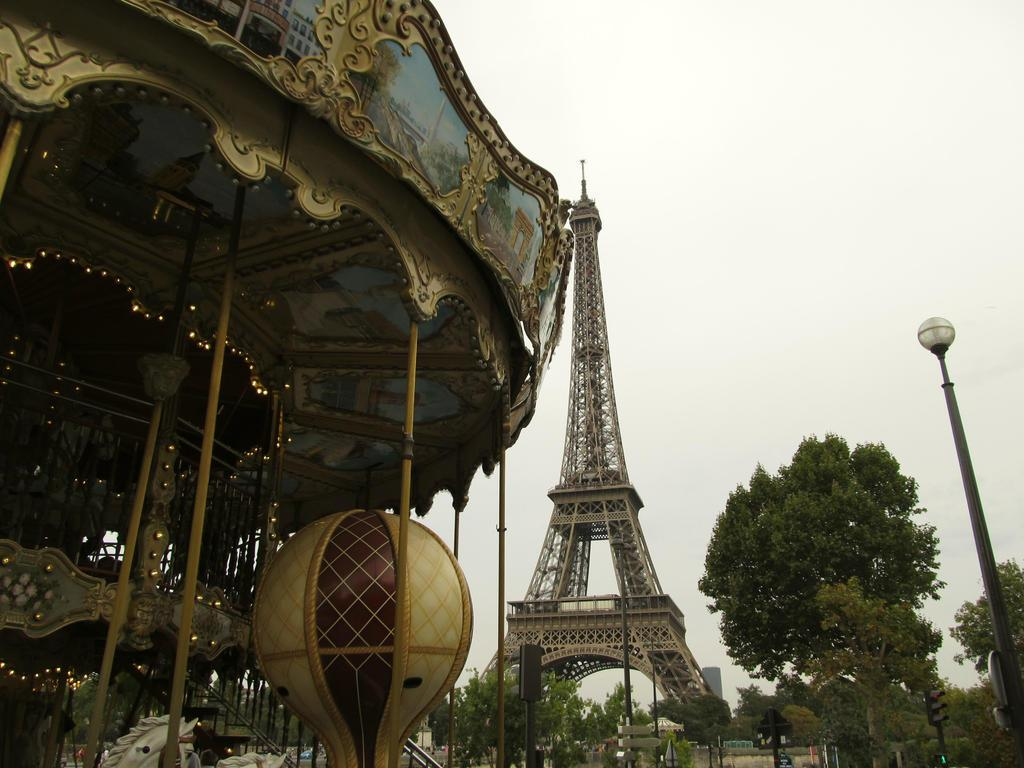What is located on the left side of the image? There is a carousel on the left side of the image. What can be seen on the right side of the image? There is light and trees on the right side of the image. What is visible in the background of the image? There is a tower, buildings, trees, and the sky visible in the background of the image. Can you tell me where the base of the carousel is located in the image? The provided facts do not mention a base for the carousel, so it cannot be determined from the image. What type of bottle is being used to say good-bye in the image? There is no bottle or good-bye gesture present in the image. 